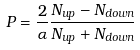<formula> <loc_0><loc_0><loc_500><loc_500>P = \frac { 2 } { \alpha } \frac { N _ { u p } - N _ { d o w n } } { N _ { u p } + N _ { d o w n } }</formula> 